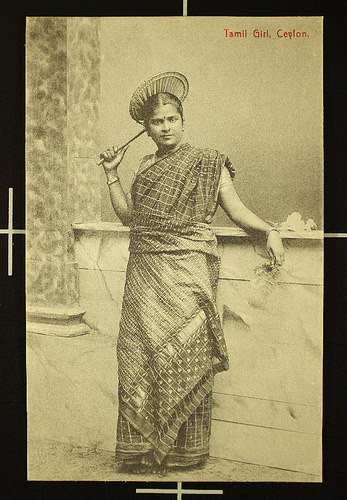<image>
Is there a woman above the wall? No. The woman is not positioned above the wall. The vertical arrangement shows a different relationship. 